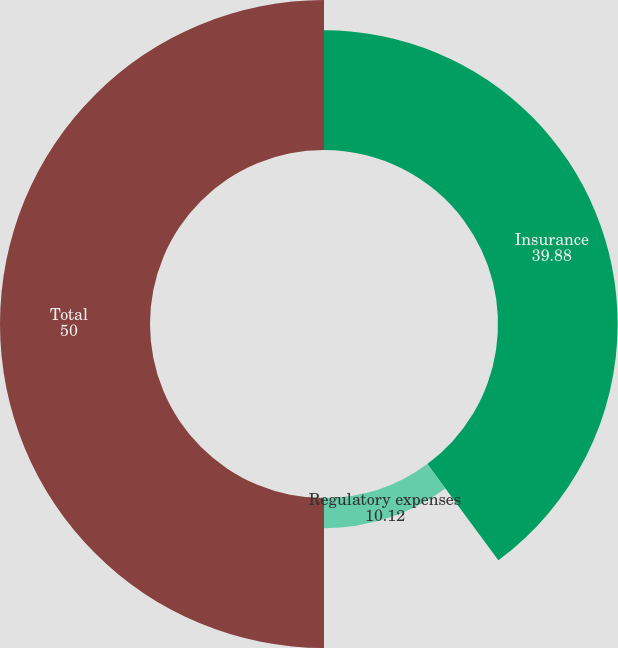Convert chart to OTSL. <chart><loc_0><loc_0><loc_500><loc_500><pie_chart><fcel>Insurance<fcel>Regulatory expenses<fcel>Total<nl><fcel>39.88%<fcel>10.12%<fcel>50.0%<nl></chart> 